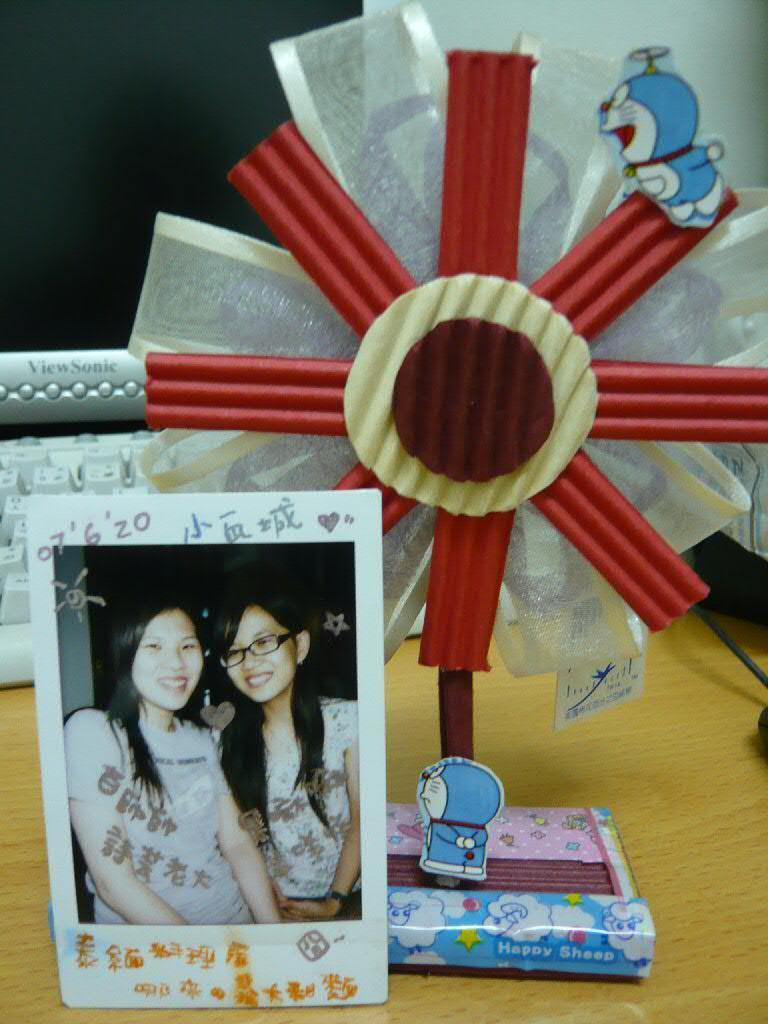What is on the table in the image? There is a photo frame, a monitor, and a keyboard on the table in the image. What is inside the photo frame? The photo frame contains a picture of two women standing. What other objects can be seen on the table? There are other objects on the table, but their specific details are not mentioned in the provided facts. How does the pollution affect the women in the picture? There is no mention of pollution in the image, so it cannot be determined how it might affect the women in the picture. 